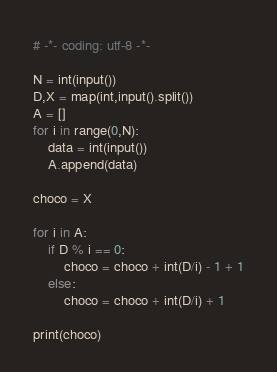Convert code to text. <code><loc_0><loc_0><loc_500><loc_500><_Python_># -*- coding: utf-8 -*-

N = int(input())
D,X = map(int,input().split())
A = []
for i in range(0,N):
    data = int(input())
    A.append(data)

choco = X

for i in A:
    if D % i == 0: 
        choco = choco + int(D/i) - 1 + 1
    else:
        choco = choco + int(D/i) + 1

print(choco)</code> 